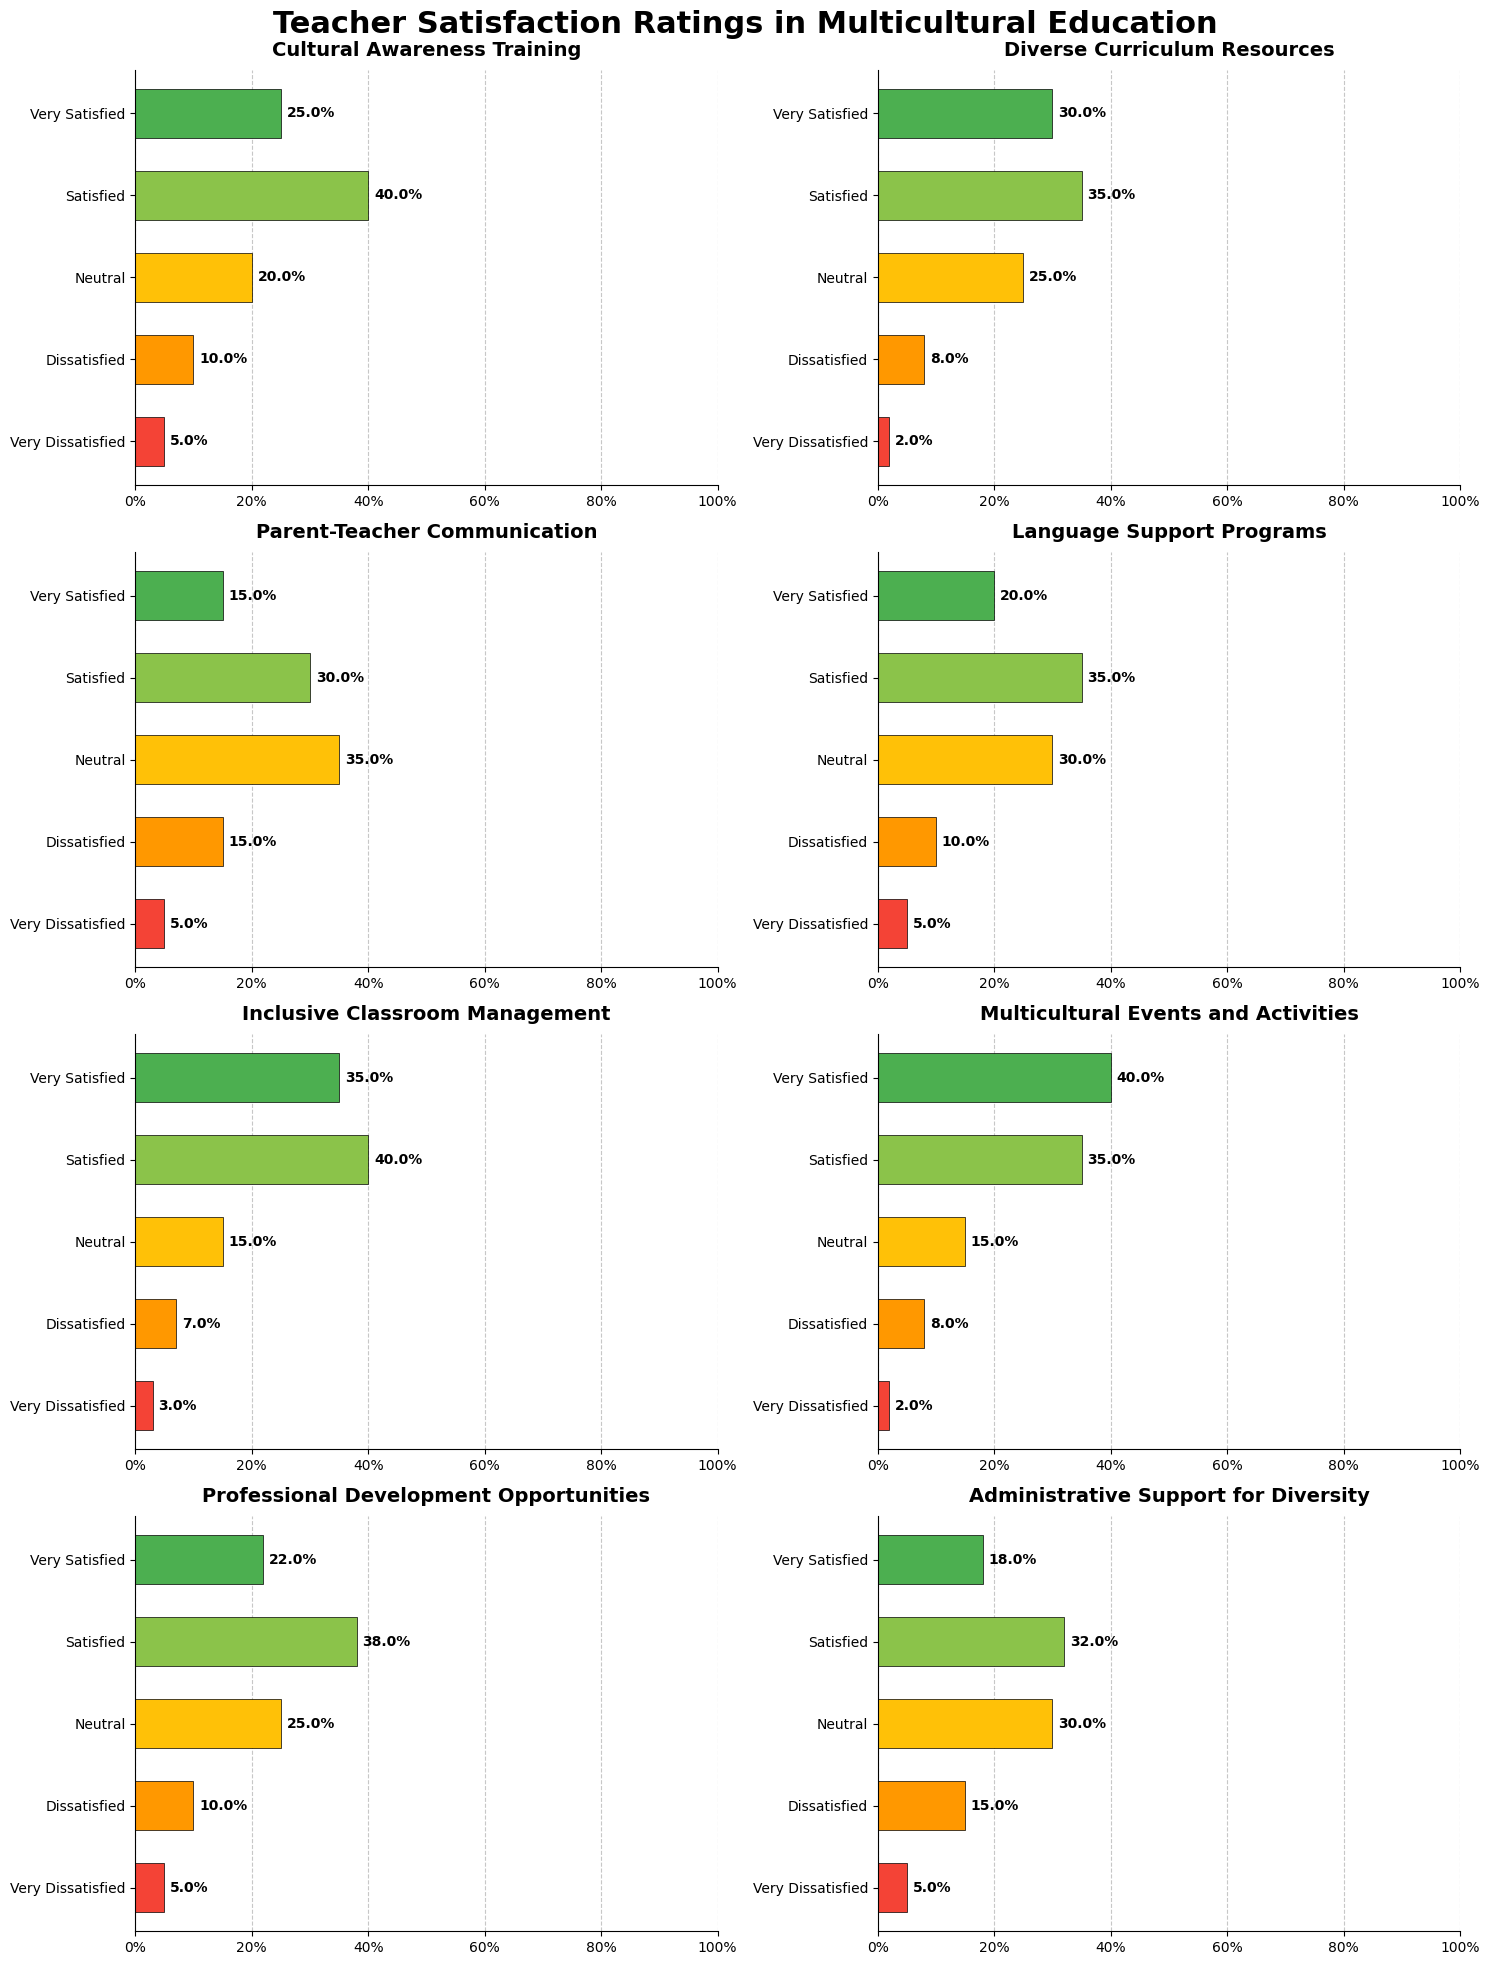What is the title of the figure? The title is usually found at the top of the figure. In this case, it reads "Teacher Satisfaction Ratings in Multicultural Education."
Answer: Teacher Satisfaction Ratings in Multicultural Education What colors are used to represent different satisfaction levels in the figure? The colors represent different levels of satisfaction. Specifically, green shades are used for "Very Satisfied" and "Satisfied," yellow for "Neutral," and red shades for "Dissatisfied" and "Very Dissatisfied."
Answer: Green, Yellow, Red Which aspect has the highest percentage of teachers who are "Very Satisfied"? By examining the horizontal bars in each subplot, "Multicultural Events and Activities" has the longest bar for "Very Satisfied" at 40%.
Answer: Multicultural Events and Activities What is the combination of "Very Satisfied" and "Satisfied" percentages for Cultural Awareness Training? Add the "Very Satisfied" and "Satisfied" percentages for Cultural Awareness Training: 25% (Very Satisfied) + 40% (Satisfied) = 65%.
Answer: 65% How many aspects have more than 50% of teachers responding as either "Very Satisfied" or "Satisfied"? Identify aspects where the sum of "Very Satisfied" and "Satisfied" percentages is more than 50%. The aspects are Cultural Awareness Training, Diverse Curriculum Resources, Language Support Programs, Inclusive Classroom Management, Multicultural Events and Activities, and Professional Development Opportunities, so there are six in total.
Answer: 6 Which aspect has the highest percentage of "Neutral" satisfaction? "Parent-Teacher Communication" has the longest bar for "Neutral" at 35%.
Answer: Parent-Teacher Communication What is the average percentage of teachers who are "Dissatisfied" across all aspects? Add the "Dissatisfied" percentages of each aspect and divide by the number of aspects: (10 + 8 + 15 + 10 + 7 + 8 + 10 + 15) / 8 = 10.375%.
Answer: 10.375% Which aspect has the lowest percentage of negative satisfaction ("Dissatisfied" and "Very Dissatisfied" combined)? Calculate the sum of "Dissatisfied" and "Very Dissatisfied" for each aspect and find the smallest: 
- Cultural Awareness Training: 10 + 5 = 15%
- Diverse Curriculum Resources: 8 + 2 = 10%
- Parent-Teacher Communication: 15 + 5 = 20%
- Language Support Programs: 10 + 5 = 15%
- Inclusive Classroom Management: 7 + 3 = 10%
- Multicultural Events and Activities: 8 + 2 = 10%
- Professional Development Opportunities: 10 + 5 = 15%
- Administrative Support for Diversity: 15 + 5 = 20%
Several aspects tie with the lowest at 10%.
Answer: Diverse Curriculum Resources, Inclusive Classroom Management, Multicultural Events and Activities Which aspect has the highest percentage of combined dissatisfied ratings ("Dissatisfied" and "Very Dissatisfied")? Add "Dissatisfied" and "Very Dissatisfied" for each aspect and identify the highest:
- Cultural Awareness Training: 10 + 5 = 15%
- Diverse Curriculum Resources: 8 + 2 = 10%
- Parent-Teacher Communication: 15 + 5 = 20%
- Language Support Programs: 10 + 5 = 15%
- Inclusive Classroom Management: 7 + 3 = 10%
- Multicultural Events and Activities: 8 + 2 = 10%
- Professional Development Opportunities: 10 + 5 = 15%
- Administrative Support for Diversity: 15 + 5 = 20%
"Parent-Teacher Communication" and "Administrative Support for Diversity" tie with the highest at 20%.
Answer: Parent-Teacher Communication, Administrative Support for Diversity 